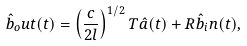<formula> <loc_0><loc_0><loc_500><loc_500>\hat { b } _ { o } u t ( t ) = \left ( \frac { c } { 2 l } \right ) ^ { 1 / 2 } T \hat { a } ( t ) + R \hat { b } _ { i } n ( t ) ,</formula> 